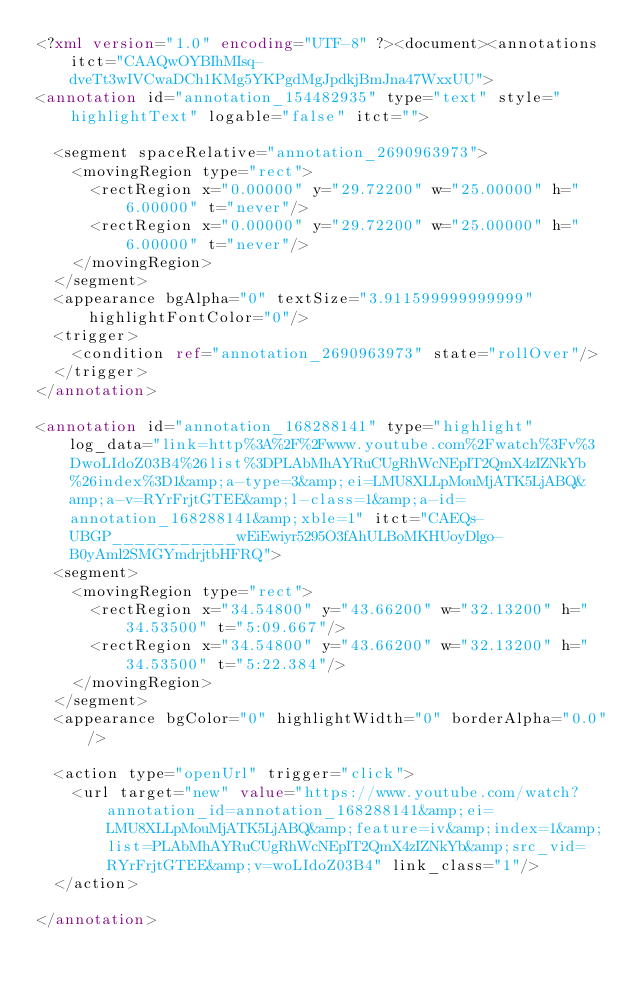Convert code to text. <code><loc_0><loc_0><loc_500><loc_500><_XML_><?xml version="1.0" encoding="UTF-8" ?><document><annotations itct="CAAQwOYBIhMIsq-dveTt3wIVCwaDCh1KMg5YKPgdMgJpdkjBmJna47WxxUU">
<annotation id="annotation_154482935" type="text" style="highlightText" logable="false" itct="">
  
  <segment spaceRelative="annotation_2690963973">
    <movingRegion type="rect">
      <rectRegion x="0.00000" y="29.72200" w="25.00000" h="6.00000" t="never"/>
      <rectRegion x="0.00000" y="29.72200" w="25.00000" h="6.00000" t="never"/>
    </movingRegion>
  </segment>
  <appearance bgAlpha="0" textSize="3.911599999999999" highlightFontColor="0"/>
  <trigger>
    <condition ref="annotation_2690963973" state="rollOver"/>
  </trigger>
</annotation>

<annotation id="annotation_168288141" type="highlight" log_data="link=http%3A%2F%2Fwww.youtube.com%2Fwatch%3Fv%3DwoLIdoZ03B4%26list%3DPLAbMhAYRuCUgRhWcNEpIT2QmX4zIZNkYb%26index%3D1&amp;a-type=3&amp;ei=LMU8XLLpMouMjATK5LjABQ&amp;a-v=RYrFrjtGTEE&amp;l-class=1&amp;a-id=annotation_168288141&amp;xble=1" itct="CAEQs-UBGP___________wEiEwiyr5295O3fAhULBoMKHUoyDlgo-B0yAml2SMGYmdrjtbHFRQ">
  <segment>
    <movingRegion type="rect">
      <rectRegion x="34.54800" y="43.66200" w="32.13200" h="34.53500" t="5:09.667"/>
      <rectRegion x="34.54800" y="43.66200" w="32.13200" h="34.53500" t="5:22.384"/>
    </movingRegion>
  </segment>
  <appearance bgColor="0" highlightWidth="0" borderAlpha="0.0"/>
  
  <action type="openUrl" trigger="click">
    <url target="new" value="https://www.youtube.com/watch?annotation_id=annotation_168288141&amp;ei=LMU8XLLpMouMjATK5LjABQ&amp;feature=iv&amp;index=1&amp;list=PLAbMhAYRuCUgRhWcNEpIT2QmX4zIZNkYb&amp;src_vid=RYrFrjtGTEE&amp;v=woLIdoZ03B4" link_class="1"/>
  </action>

</annotation>
</code> 